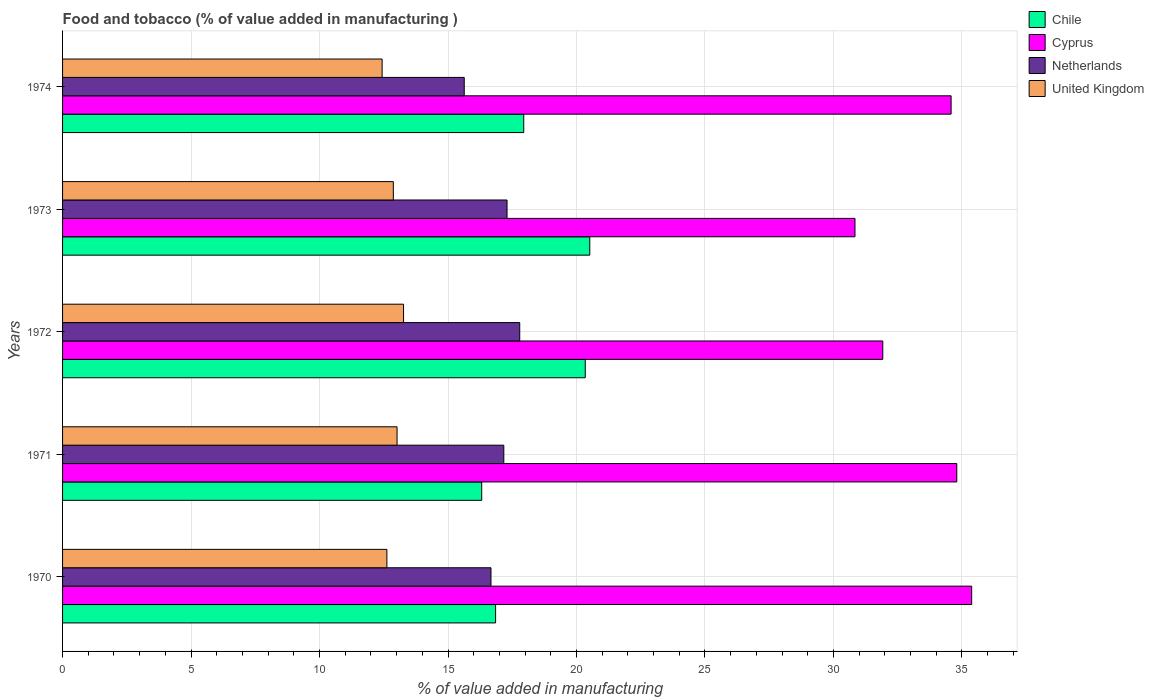How many groups of bars are there?
Provide a short and direct response. 5. Are the number of bars per tick equal to the number of legend labels?
Your answer should be very brief. Yes. Are the number of bars on each tick of the Y-axis equal?
Offer a terse response. Yes. How many bars are there on the 5th tick from the bottom?
Provide a short and direct response. 4. What is the label of the 5th group of bars from the top?
Provide a succinct answer. 1970. What is the value added in manufacturing food and tobacco in Chile in 1971?
Ensure brevity in your answer.  16.31. Across all years, what is the maximum value added in manufacturing food and tobacco in Chile?
Give a very brief answer. 20.52. Across all years, what is the minimum value added in manufacturing food and tobacco in United Kingdom?
Ensure brevity in your answer.  12.44. In which year was the value added in manufacturing food and tobacco in United Kingdom minimum?
Your answer should be very brief. 1974. What is the total value added in manufacturing food and tobacco in Netherlands in the graph?
Your answer should be very brief. 84.56. What is the difference between the value added in manufacturing food and tobacco in United Kingdom in 1971 and that in 1974?
Offer a terse response. 0.58. What is the difference between the value added in manufacturing food and tobacco in Netherlands in 1972 and the value added in manufacturing food and tobacco in Chile in 1974?
Your answer should be compact. -0.16. What is the average value added in manufacturing food and tobacco in United Kingdom per year?
Give a very brief answer. 12.84. In the year 1974, what is the difference between the value added in manufacturing food and tobacco in Netherlands and value added in manufacturing food and tobacco in Chile?
Provide a succinct answer. -2.32. What is the ratio of the value added in manufacturing food and tobacco in Netherlands in 1971 to that in 1972?
Offer a very short reply. 0.97. Is the value added in manufacturing food and tobacco in Cyprus in 1970 less than that in 1974?
Your answer should be compact. No. What is the difference between the highest and the second highest value added in manufacturing food and tobacco in Cyprus?
Ensure brevity in your answer.  0.58. What is the difference between the highest and the lowest value added in manufacturing food and tobacco in Netherlands?
Your answer should be very brief. 2.16. What does the 2nd bar from the bottom in 1971 represents?
Your response must be concise. Cyprus. How many years are there in the graph?
Ensure brevity in your answer.  5. What is the difference between two consecutive major ticks on the X-axis?
Provide a succinct answer. 5. Are the values on the major ticks of X-axis written in scientific E-notation?
Keep it short and to the point. No. Does the graph contain grids?
Provide a short and direct response. Yes. Where does the legend appear in the graph?
Offer a very short reply. Top right. How are the legend labels stacked?
Make the answer very short. Vertical. What is the title of the graph?
Provide a short and direct response. Food and tobacco (% of value added in manufacturing ). Does "Bahrain" appear as one of the legend labels in the graph?
Offer a very short reply. No. What is the label or title of the X-axis?
Offer a very short reply. % of value added in manufacturing. What is the % of value added in manufacturing in Chile in 1970?
Give a very brief answer. 16.85. What is the % of value added in manufacturing in Cyprus in 1970?
Your answer should be very brief. 35.38. What is the % of value added in manufacturing of Netherlands in 1970?
Your answer should be very brief. 16.67. What is the % of value added in manufacturing in United Kingdom in 1970?
Provide a short and direct response. 12.62. What is the % of value added in manufacturing of Chile in 1971?
Provide a succinct answer. 16.31. What is the % of value added in manufacturing of Cyprus in 1971?
Your answer should be compact. 34.8. What is the % of value added in manufacturing in Netherlands in 1971?
Your answer should be compact. 17.17. What is the % of value added in manufacturing in United Kingdom in 1971?
Offer a terse response. 13.02. What is the % of value added in manufacturing of Chile in 1972?
Give a very brief answer. 20.34. What is the % of value added in manufacturing of Cyprus in 1972?
Provide a succinct answer. 31.92. What is the % of value added in manufacturing of Netherlands in 1972?
Your answer should be very brief. 17.79. What is the % of value added in manufacturing of United Kingdom in 1972?
Give a very brief answer. 13.27. What is the % of value added in manufacturing in Chile in 1973?
Give a very brief answer. 20.52. What is the % of value added in manufacturing of Cyprus in 1973?
Your response must be concise. 30.84. What is the % of value added in manufacturing of Netherlands in 1973?
Ensure brevity in your answer.  17.3. What is the % of value added in manufacturing in United Kingdom in 1973?
Make the answer very short. 12.87. What is the % of value added in manufacturing in Chile in 1974?
Ensure brevity in your answer.  17.95. What is the % of value added in manufacturing in Cyprus in 1974?
Offer a very short reply. 34.58. What is the % of value added in manufacturing of Netherlands in 1974?
Give a very brief answer. 15.63. What is the % of value added in manufacturing in United Kingdom in 1974?
Give a very brief answer. 12.44. Across all years, what is the maximum % of value added in manufacturing in Chile?
Your answer should be very brief. 20.52. Across all years, what is the maximum % of value added in manufacturing of Cyprus?
Your answer should be compact. 35.38. Across all years, what is the maximum % of value added in manufacturing in Netherlands?
Your answer should be very brief. 17.79. Across all years, what is the maximum % of value added in manufacturing of United Kingdom?
Provide a succinct answer. 13.27. Across all years, what is the minimum % of value added in manufacturing of Chile?
Give a very brief answer. 16.31. Across all years, what is the minimum % of value added in manufacturing in Cyprus?
Provide a succinct answer. 30.84. Across all years, what is the minimum % of value added in manufacturing in Netherlands?
Make the answer very short. 15.63. Across all years, what is the minimum % of value added in manufacturing in United Kingdom?
Offer a terse response. 12.44. What is the total % of value added in manufacturing of Chile in the graph?
Offer a very short reply. 91.97. What is the total % of value added in manufacturing in Cyprus in the graph?
Your answer should be compact. 167.51. What is the total % of value added in manufacturing in Netherlands in the graph?
Keep it short and to the point. 84.56. What is the total % of value added in manufacturing in United Kingdom in the graph?
Ensure brevity in your answer.  64.22. What is the difference between the % of value added in manufacturing of Chile in 1970 and that in 1971?
Make the answer very short. 0.54. What is the difference between the % of value added in manufacturing of Cyprus in 1970 and that in 1971?
Offer a very short reply. 0.58. What is the difference between the % of value added in manufacturing in Netherlands in 1970 and that in 1971?
Keep it short and to the point. -0.5. What is the difference between the % of value added in manufacturing in United Kingdom in 1970 and that in 1971?
Provide a succinct answer. -0.4. What is the difference between the % of value added in manufacturing of Chile in 1970 and that in 1972?
Make the answer very short. -3.49. What is the difference between the % of value added in manufacturing of Cyprus in 1970 and that in 1972?
Make the answer very short. 3.46. What is the difference between the % of value added in manufacturing in Netherlands in 1970 and that in 1972?
Give a very brief answer. -1.12. What is the difference between the % of value added in manufacturing of United Kingdom in 1970 and that in 1972?
Keep it short and to the point. -0.65. What is the difference between the % of value added in manufacturing in Chile in 1970 and that in 1973?
Your response must be concise. -3.67. What is the difference between the % of value added in manufacturing in Cyprus in 1970 and that in 1973?
Offer a terse response. 4.54. What is the difference between the % of value added in manufacturing of Netherlands in 1970 and that in 1973?
Your answer should be compact. -0.62. What is the difference between the % of value added in manufacturing of United Kingdom in 1970 and that in 1973?
Offer a terse response. -0.25. What is the difference between the % of value added in manufacturing in Chile in 1970 and that in 1974?
Keep it short and to the point. -1.1. What is the difference between the % of value added in manufacturing in Cyprus in 1970 and that in 1974?
Give a very brief answer. 0.8. What is the difference between the % of value added in manufacturing of Netherlands in 1970 and that in 1974?
Make the answer very short. 1.04. What is the difference between the % of value added in manufacturing in United Kingdom in 1970 and that in 1974?
Your response must be concise. 0.19. What is the difference between the % of value added in manufacturing in Chile in 1971 and that in 1972?
Provide a succinct answer. -4.03. What is the difference between the % of value added in manufacturing in Cyprus in 1971 and that in 1972?
Provide a succinct answer. 2.88. What is the difference between the % of value added in manufacturing of Netherlands in 1971 and that in 1972?
Ensure brevity in your answer.  -0.62. What is the difference between the % of value added in manufacturing in United Kingdom in 1971 and that in 1972?
Offer a very short reply. -0.25. What is the difference between the % of value added in manufacturing in Chile in 1971 and that in 1973?
Make the answer very short. -4.2. What is the difference between the % of value added in manufacturing in Cyprus in 1971 and that in 1973?
Ensure brevity in your answer.  3.96. What is the difference between the % of value added in manufacturing of Netherlands in 1971 and that in 1973?
Give a very brief answer. -0.13. What is the difference between the % of value added in manufacturing in United Kingdom in 1971 and that in 1973?
Provide a short and direct response. 0.15. What is the difference between the % of value added in manufacturing in Chile in 1971 and that in 1974?
Provide a succinct answer. -1.63. What is the difference between the % of value added in manufacturing of Cyprus in 1971 and that in 1974?
Provide a succinct answer. 0.22. What is the difference between the % of value added in manufacturing of Netherlands in 1971 and that in 1974?
Your response must be concise. 1.54. What is the difference between the % of value added in manufacturing in United Kingdom in 1971 and that in 1974?
Your response must be concise. 0.58. What is the difference between the % of value added in manufacturing of Chile in 1972 and that in 1973?
Keep it short and to the point. -0.18. What is the difference between the % of value added in manufacturing in Cyprus in 1972 and that in 1973?
Ensure brevity in your answer.  1.08. What is the difference between the % of value added in manufacturing of Netherlands in 1972 and that in 1973?
Provide a short and direct response. 0.49. What is the difference between the % of value added in manufacturing in United Kingdom in 1972 and that in 1973?
Provide a short and direct response. 0.4. What is the difference between the % of value added in manufacturing of Chile in 1972 and that in 1974?
Offer a terse response. 2.39. What is the difference between the % of value added in manufacturing of Cyprus in 1972 and that in 1974?
Provide a succinct answer. -2.66. What is the difference between the % of value added in manufacturing in Netherlands in 1972 and that in 1974?
Your answer should be compact. 2.16. What is the difference between the % of value added in manufacturing in United Kingdom in 1972 and that in 1974?
Ensure brevity in your answer.  0.83. What is the difference between the % of value added in manufacturing in Chile in 1973 and that in 1974?
Give a very brief answer. 2.57. What is the difference between the % of value added in manufacturing of Cyprus in 1973 and that in 1974?
Offer a very short reply. -3.74. What is the difference between the % of value added in manufacturing of Netherlands in 1973 and that in 1974?
Make the answer very short. 1.67. What is the difference between the % of value added in manufacturing of United Kingdom in 1973 and that in 1974?
Offer a very short reply. 0.44. What is the difference between the % of value added in manufacturing of Chile in 1970 and the % of value added in manufacturing of Cyprus in 1971?
Your response must be concise. -17.95. What is the difference between the % of value added in manufacturing in Chile in 1970 and the % of value added in manufacturing in Netherlands in 1971?
Your response must be concise. -0.32. What is the difference between the % of value added in manufacturing in Chile in 1970 and the % of value added in manufacturing in United Kingdom in 1971?
Offer a very short reply. 3.83. What is the difference between the % of value added in manufacturing of Cyprus in 1970 and the % of value added in manufacturing of Netherlands in 1971?
Offer a very short reply. 18.21. What is the difference between the % of value added in manufacturing of Cyprus in 1970 and the % of value added in manufacturing of United Kingdom in 1971?
Offer a very short reply. 22.36. What is the difference between the % of value added in manufacturing of Netherlands in 1970 and the % of value added in manufacturing of United Kingdom in 1971?
Your answer should be very brief. 3.66. What is the difference between the % of value added in manufacturing in Chile in 1970 and the % of value added in manufacturing in Cyprus in 1972?
Offer a terse response. -15.07. What is the difference between the % of value added in manufacturing in Chile in 1970 and the % of value added in manufacturing in Netherlands in 1972?
Provide a succinct answer. -0.94. What is the difference between the % of value added in manufacturing of Chile in 1970 and the % of value added in manufacturing of United Kingdom in 1972?
Offer a very short reply. 3.58. What is the difference between the % of value added in manufacturing of Cyprus in 1970 and the % of value added in manufacturing of Netherlands in 1972?
Provide a succinct answer. 17.59. What is the difference between the % of value added in manufacturing of Cyprus in 1970 and the % of value added in manufacturing of United Kingdom in 1972?
Ensure brevity in your answer.  22.11. What is the difference between the % of value added in manufacturing in Netherlands in 1970 and the % of value added in manufacturing in United Kingdom in 1972?
Provide a short and direct response. 3.4. What is the difference between the % of value added in manufacturing in Chile in 1970 and the % of value added in manufacturing in Cyprus in 1973?
Provide a succinct answer. -13.99. What is the difference between the % of value added in manufacturing of Chile in 1970 and the % of value added in manufacturing of Netherlands in 1973?
Your answer should be very brief. -0.45. What is the difference between the % of value added in manufacturing in Chile in 1970 and the % of value added in manufacturing in United Kingdom in 1973?
Offer a very short reply. 3.98. What is the difference between the % of value added in manufacturing of Cyprus in 1970 and the % of value added in manufacturing of Netherlands in 1973?
Ensure brevity in your answer.  18.08. What is the difference between the % of value added in manufacturing in Cyprus in 1970 and the % of value added in manufacturing in United Kingdom in 1973?
Provide a short and direct response. 22.51. What is the difference between the % of value added in manufacturing in Netherlands in 1970 and the % of value added in manufacturing in United Kingdom in 1973?
Provide a succinct answer. 3.8. What is the difference between the % of value added in manufacturing of Chile in 1970 and the % of value added in manufacturing of Cyprus in 1974?
Ensure brevity in your answer.  -17.73. What is the difference between the % of value added in manufacturing of Chile in 1970 and the % of value added in manufacturing of Netherlands in 1974?
Ensure brevity in your answer.  1.22. What is the difference between the % of value added in manufacturing in Chile in 1970 and the % of value added in manufacturing in United Kingdom in 1974?
Provide a succinct answer. 4.42. What is the difference between the % of value added in manufacturing of Cyprus in 1970 and the % of value added in manufacturing of Netherlands in 1974?
Your answer should be very brief. 19.75. What is the difference between the % of value added in manufacturing in Cyprus in 1970 and the % of value added in manufacturing in United Kingdom in 1974?
Provide a succinct answer. 22.94. What is the difference between the % of value added in manufacturing in Netherlands in 1970 and the % of value added in manufacturing in United Kingdom in 1974?
Offer a terse response. 4.24. What is the difference between the % of value added in manufacturing of Chile in 1971 and the % of value added in manufacturing of Cyprus in 1972?
Offer a terse response. -15.61. What is the difference between the % of value added in manufacturing of Chile in 1971 and the % of value added in manufacturing of Netherlands in 1972?
Provide a succinct answer. -1.48. What is the difference between the % of value added in manufacturing of Chile in 1971 and the % of value added in manufacturing of United Kingdom in 1972?
Provide a short and direct response. 3.04. What is the difference between the % of value added in manufacturing in Cyprus in 1971 and the % of value added in manufacturing in Netherlands in 1972?
Your response must be concise. 17.01. What is the difference between the % of value added in manufacturing of Cyprus in 1971 and the % of value added in manufacturing of United Kingdom in 1972?
Offer a very short reply. 21.53. What is the difference between the % of value added in manufacturing in Netherlands in 1971 and the % of value added in manufacturing in United Kingdom in 1972?
Provide a short and direct response. 3.9. What is the difference between the % of value added in manufacturing in Chile in 1971 and the % of value added in manufacturing in Cyprus in 1973?
Your response must be concise. -14.53. What is the difference between the % of value added in manufacturing in Chile in 1971 and the % of value added in manufacturing in Netherlands in 1973?
Offer a terse response. -0.99. What is the difference between the % of value added in manufacturing in Chile in 1971 and the % of value added in manufacturing in United Kingdom in 1973?
Make the answer very short. 3.44. What is the difference between the % of value added in manufacturing in Cyprus in 1971 and the % of value added in manufacturing in Netherlands in 1973?
Give a very brief answer. 17.5. What is the difference between the % of value added in manufacturing of Cyprus in 1971 and the % of value added in manufacturing of United Kingdom in 1973?
Offer a very short reply. 21.93. What is the difference between the % of value added in manufacturing in Netherlands in 1971 and the % of value added in manufacturing in United Kingdom in 1973?
Your answer should be very brief. 4.3. What is the difference between the % of value added in manufacturing in Chile in 1971 and the % of value added in manufacturing in Cyprus in 1974?
Give a very brief answer. -18.27. What is the difference between the % of value added in manufacturing of Chile in 1971 and the % of value added in manufacturing of Netherlands in 1974?
Give a very brief answer. 0.68. What is the difference between the % of value added in manufacturing in Chile in 1971 and the % of value added in manufacturing in United Kingdom in 1974?
Provide a short and direct response. 3.88. What is the difference between the % of value added in manufacturing in Cyprus in 1971 and the % of value added in manufacturing in Netherlands in 1974?
Keep it short and to the point. 19.17. What is the difference between the % of value added in manufacturing of Cyprus in 1971 and the % of value added in manufacturing of United Kingdom in 1974?
Offer a very short reply. 22.36. What is the difference between the % of value added in manufacturing in Netherlands in 1971 and the % of value added in manufacturing in United Kingdom in 1974?
Your answer should be compact. 4.74. What is the difference between the % of value added in manufacturing in Chile in 1972 and the % of value added in manufacturing in Cyprus in 1973?
Make the answer very short. -10.5. What is the difference between the % of value added in manufacturing in Chile in 1972 and the % of value added in manufacturing in Netherlands in 1973?
Your answer should be compact. 3.04. What is the difference between the % of value added in manufacturing in Chile in 1972 and the % of value added in manufacturing in United Kingdom in 1973?
Your answer should be very brief. 7.47. What is the difference between the % of value added in manufacturing of Cyprus in 1972 and the % of value added in manufacturing of Netherlands in 1973?
Ensure brevity in your answer.  14.62. What is the difference between the % of value added in manufacturing in Cyprus in 1972 and the % of value added in manufacturing in United Kingdom in 1973?
Your response must be concise. 19.05. What is the difference between the % of value added in manufacturing in Netherlands in 1972 and the % of value added in manufacturing in United Kingdom in 1973?
Your answer should be compact. 4.92. What is the difference between the % of value added in manufacturing of Chile in 1972 and the % of value added in manufacturing of Cyprus in 1974?
Keep it short and to the point. -14.24. What is the difference between the % of value added in manufacturing of Chile in 1972 and the % of value added in manufacturing of Netherlands in 1974?
Offer a very short reply. 4.71. What is the difference between the % of value added in manufacturing of Chile in 1972 and the % of value added in manufacturing of United Kingdom in 1974?
Keep it short and to the point. 7.91. What is the difference between the % of value added in manufacturing in Cyprus in 1972 and the % of value added in manufacturing in Netherlands in 1974?
Give a very brief answer. 16.29. What is the difference between the % of value added in manufacturing in Cyprus in 1972 and the % of value added in manufacturing in United Kingdom in 1974?
Ensure brevity in your answer.  19.48. What is the difference between the % of value added in manufacturing of Netherlands in 1972 and the % of value added in manufacturing of United Kingdom in 1974?
Keep it short and to the point. 5.36. What is the difference between the % of value added in manufacturing of Chile in 1973 and the % of value added in manufacturing of Cyprus in 1974?
Make the answer very short. -14.06. What is the difference between the % of value added in manufacturing in Chile in 1973 and the % of value added in manufacturing in Netherlands in 1974?
Offer a very short reply. 4.89. What is the difference between the % of value added in manufacturing in Chile in 1973 and the % of value added in manufacturing in United Kingdom in 1974?
Provide a short and direct response. 8.08. What is the difference between the % of value added in manufacturing of Cyprus in 1973 and the % of value added in manufacturing of Netherlands in 1974?
Provide a succinct answer. 15.21. What is the difference between the % of value added in manufacturing in Cyprus in 1973 and the % of value added in manufacturing in United Kingdom in 1974?
Your answer should be very brief. 18.4. What is the difference between the % of value added in manufacturing of Netherlands in 1973 and the % of value added in manufacturing of United Kingdom in 1974?
Provide a short and direct response. 4.86. What is the average % of value added in manufacturing in Chile per year?
Give a very brief answer. 18.39. What is the average % of value added in manufacturing in Cyprus per year?
Ensure brevity in your answer.  33.5. What is the average % of value added in manufacturing in Netherlands per year?
Your answer should be compact. 16.91. What is the average % of value added in manufacturing in United Kingdom per year?
Your response must be concise. 12.84. In the year 1970, what is the difference between the % of value added in manufacturing of Chile and % of value added in manufacturing of Cyprus?
Provide a short and direct response. -18.53. In the year 1970, what is the difference between the % of value added in manufacturing of Chile and % of value added in manufacturing of Netherlands?
Ensure brevity in your answer.  0.18. In the year 1970, what is the difference between the % of value added in manufacturing of Chile and % of value added in manufacturing of United Kingdom?
Keep it short and to the point. 4.23. In the year 1970, what is the difference between the % of value added in manufacturing of Cyprus and % of value added in manufacturing of Netherlands?
Provide a succinct answer. 18.71. In the year 1970, what is the difference between the % of value added in manufacturing in Cyprus and % of value added in manufacturing in United Kingdom?
Your answer should be compact. 22.76. In the year 1970, what is the difference between the % of value added in manufacturing in Netherlands and % of value added in manufacturing in United Kingdom?
Your answer should be compact. 4.05. In the year 1971, what is the difference between the % of value added in manufacturing in Chile and % of value added in manufacturing in Cyprus?
Your answer should be very brief. -18.49. In the year 1971, what is the difference between the % of value added in manufacturing in Chile and % of value added in manufacturing in Netherlands?
Give a very brief answer. -0.86. In the year 1971, what is the difference between the % of value added in manufacturing in Chile and % of value added in manufacturing in United Kingdom?
Offer a terse response. 3.29. In the year 1971, what is the difference between the % of value added in manufacturing of Cyprus and % of value added in manufacturing of Netherlands?
Provide a short and direct response. 17.63. In the year 1971, what is the difference between the % of value added in manufacturing in Cyprus and % of value added in manufacturing in United Kingdom?
Your answer should be compact. 21.78. In the year 1971, what is the difference between the % of value added in manufacturing of Netherlands and % of value added in manufacturing of United Kingdom?
Provide a succinct answer. 4.15. In the year 1972, what is the difference between the % of value added in manufacturing in Chile and % of value added in manufacturing in Cyprus?
Your answer should be compact. -11.58. In the year 1972, what is the difference between the % of value added in manufacturing in Chile and % of value added in manufacturing in Netherlands?
Keep it short and to the point. 2.55. In the year 1972, what is the difference between the % of value added in manufacturing of Chile and % of value added in manufacturing of United Kingdom?
Provide a succinct answer. 7.07. In the year 1972, what is the difference between the % of value added in manufacturing of Cyprus and % of value added in manufacturing of Netherlands?
Keep it short and to the point. 14.13. In the year 1972, what is the difference between the % of value added in manufacturing of Cyprus and % of value added in manufacturing of United Kingdom?
Give a very brief answer. 18.65. In the year 1972, what is the difference between the % of value added in manufacturing in Netherlands and % of value added in manufacturing in United Kingdom?
Make the answer very short. 4.52. In the year 1973, what is the difference between the % of value added in manufacturing in Chile and % of value added in manufacturing in Cyprus?
Provide a succinct answer. -10.32. In the year 1973, what is the difference between the % of value added in manufacturing of Chile and % of value added in manufacturing of Netherlands?
Offer a terse response. 3.22. In the year 1973, what is the difference between the % of value added in manufacturing of Chile and % of value added in manufacturing of United Kingdom?
Your answer should be very brief. 7.64. In the year 1973, what is the difference between the % of value added in manufacturing in Cyprus and % of value added in manufacturing in Netherlands?
Your answer should be compact. 13.54. In the year 1973, what is the difference between the % of value added in manufacturing in Cyprus and % of value added in manufacturing in United Kingdom?
Your response must be concise. 17.97. In the year 1973, what is the difference between the % of value added in manufacturing in Netherlands and % of value added in manufacturing in United Kingdom?
Your answer should be compact. 4.43. In the year 1974, what is the difference between the % of value added in manufacturing in Chile and % of value added in manufacturing in Cyprus?
Provide a succinct answer. -16.63. In the year 1974, what is the difference between the % of value added in manufacturing of Chile and % of value added in manufacturing of Netherlands?
Ensure brevity in your answer.  2.32. In the year 1974, what is the difference between the % of value added in manufacturing in Chile and % of value added in manufacturing in United Kingdom?
Your response must be concise. 5.51. In the year 1974, what is the difference between the % of value added in manufacturing in Cyprus and % of value added in manufacturing in Netherlands?
Make the answer very short. 18.95. In the year 1974, what is the difference between the % of value added in manufacturing of Cyprus and % of value added in manufacturing of United Kingdom?
Your answer should be compact. 22.14. In the year 1974, what is the difference between the % of value added in manufacturing in Netherlands and % of value added in manufacturing in United Kingdom?
Ensure brevity in your answer.  3.2. What is the ratio of the % of value added in manufacturing of Chile in 1970 to that in 1971?
Ensure brevity in your answer.  1.03. What is the ratio of the % of value added in manufacturing in Cyprus in 1970 to that in 1971?
Provide a short and direct response. 1.02. What is the ratio of the % of value added in manufacturing in Netherlands in 1970 to that in 1971?
Offer a very short reply. 0.97. What is the ratio of the % of value added in manufacturing of United Kingdom in 1970 to that in 1971?
Ensure brevity in your answer.  0.97. What is the ratio of the % of value added in manufacturing of Chile in 1970 to that in 1972?
Your response must be concise. 0.83. What is the ratio of the % of value added in manufacturing in Cyprus in 1970 to that in 1972?
Give a very brief answer. 1.11. What is the ratio of the % of value added in manufacturing in Netherlands in 1970 to that in 1972?
Your answer should be very brief. 0.94. What is the ratio of the % of value added in manufacturing of United Kingdom in 1970 to that in 1972?
Make the answer very short. 0.95. What is the ratio of the % of value added in manufacturing of Chile in 1970 to that in 1973?
Your response must be concise. 0.82. What is the ratio of the % of value added in manufacturing of Cyprus in 1970 to that in 1973?
Your answer should be very brief. 1.15. What is the ratio of the % of value added in manufacturing of Netherlands in 1970 to that in 1973?
Offer a very short reply. 0.96. What is the ratio of the % of value added in manufacturing in United Kingdom in 1970 to that in 1973?
Provide a succinct answer. 0.98. What is the ratio of the % of value added in manufacturing in Chile in 1970 to that in 1974?
Provide a short and direct response. 0.94. What is the ratio of the % of value added in manufacturing in Cyprus in 1970 to that in 1974?
Ensure brevity in your answer.  1.02. What is the ratio of the % of value added in manufacturing of Netherlands in 1970 to that in 1974?
Ensure brevity in your answer.  1.07. What is the ratio of the % of value added in manufacturing in United Kingdom in 1970 to that in 1974?
Offer a very short reply. 1.01. What is the ratio of the % of value added in manufacturing in Chile in 1971 to that in 1972?
Your answer should be compact. 0.8. What is the ratio of the % of value added in manufacturing of Cyprus in 1971 to that in 1972?
Give a very brief answer. 1.09. What is the ratio of the % of value added in manufacturing in Netherlands in 1971 to that in 1972?
Offer a terse response. 0.97. What is the ratio of the % of value added in manufacturing of Chile in 1971 to that in 1973?
Give a very brief answer. 0.8. What is the ratio of the % of value added in manufacturing in Cyprus in 1971 to that in 1973?
Keep it short and to the point. 1.13. What is the ratio of the % of value added in manufacturing in United Kingdom in 1971 to that in 1973?
Provide a short and direct response. 1.01. What is the ratio of the % of value added in manufacturing in Chile in 1971 to that in 1974?
Keep it short and to the point. 0.91. What is the ratio of the % of value added in manufacturing of Cyprus in 1971 to that in 1974?
Offer a very short reply. 1.01. What is the ratio of the % of value added in manufacturing in Netherlands in 1971 to that in 1974?
Keep it short and to the point. 1.1. What is the ratio of the % of value added in manufacturing in United Kingdom in 1971 to that in 1974?
Give a very brief answer. 1.05. What is the ratio of the % of value added in manufacturing of Chile in 1972 to that in 1973?
Ensure brevity in your answer.  0.99. What is the ratio of the % of value added in manufacturing in Cyprus in 1972 to that in 1973?
Provide a short and direct response. 1.04. What is the ratio of the % of value added in manufacturing in Netherlands in 1972 to that in 1973?
Offer a very short reply. 1.03. What is the ratio of the % of value added in manufacturing of United Kingdom in 1972 to that in 1973?
Give a very brief answer. 1.03. What is the ratio of the % of value added in manufacturing of Chile in 1972 to that in 1974?
Your answer should be very brief. 1.13. What is the ratio of the % of value added in manufacturing in Netherlands in 1972 to that in 1974?
Offer a very short reply. 1.14. What is the ratio of the % of value added in manufacturing of United Kingdom in 1972 to that in 1974?
Offer a very short reply. 1.07. What is the ratio of the % of value added in manufacturing of Chile in 1973 to that in 1974?
Your answer should be compact. 1.14. What is the ratio of the % of value added in manufacturing of Cyprus in 1973 to that in 1974?
Ensure brevity in your answer.  0.89. What is the ratio of the % of value added in manufacturing of Netherlands in 1973 to that in 1974?
Your answer should be very brief. 1.11. What is the ratio of the % of value added in manufacturing in United Kingdom in 1973 to that in 1974?
Ensure brevity in your answer.  1.04. What is the difference between the highest and the second highest % of value added in manufacturing in Chile?
Give a very brief answer. 0.18. What is the difference between the highest and the second highest % of value added in manufacturing in Cyprus?
Make the answer very short. 0.58. What is the difference between the highest and the second highest % of value added in manufacturing of Netherlands?
Give a very brief answer. 0.49. What is the difference between the highest and the second highest % of value added in manufacturing in United Kingdom?
Give a very brief answer. 0.25. What is the difference between the highest and the lowest % of value added in manufacturing in Chile?
Ensure brevity in your answer.  4.2. What is the difference between the highest and the lowest % of value added in manufacturing in Cyprus?
Make the answer very short. 4.54. What is the difference between the highest and the lowest % of value added in manufacturing in Netherlands?
Keep it short and to the point. 2.16. What is the difference between the highest and the lowest % of value added in manufacturing in United Kingdom?
Your response must be concise. 0.83. 